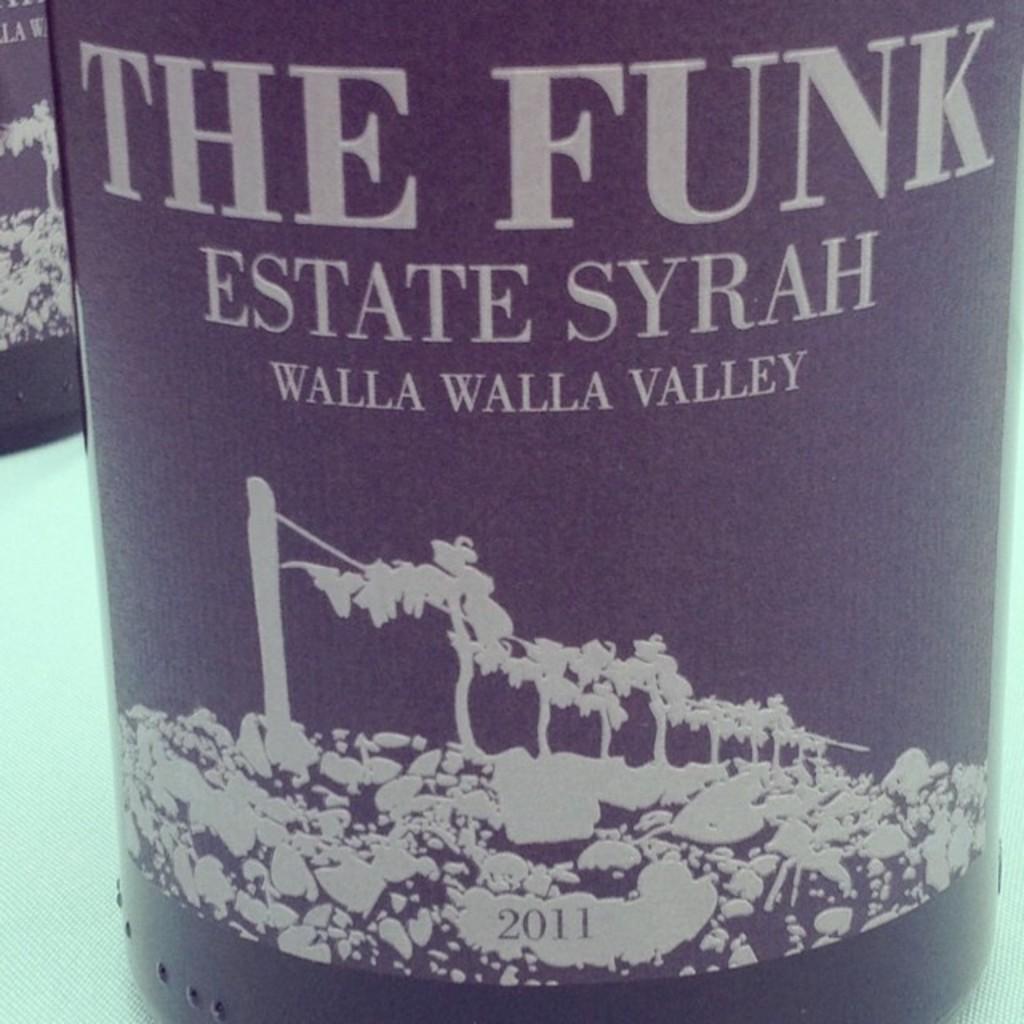Please provide a concise description of this image. In this picture, we see a black color glass bottle is placed on the white table. On the bottle it is written as"THE FUNK". Beside that, we see another glass bottle. 